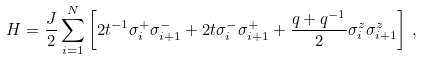Convert formula to latex. <formula><loc_0><loc_0><loc_500><loc_500>H = \frac { J } { 2 } \sum ^ { N } _ { i = 1 } \left [ 2 t ^ { - 1 } \sigma _ { i } ^ { + } \sigma _ { i + 1 } ^ { - } + 2 t \sigma _ { i } ^ { - } \sigma _ { i + 1 } ^ { + } + \frac { q + q ^ { - 1 } } { 2 } \sigma _ { i } ^ { z } \sigma _ { i + 1 } ^ { z } \right ] \, ,</formula> 